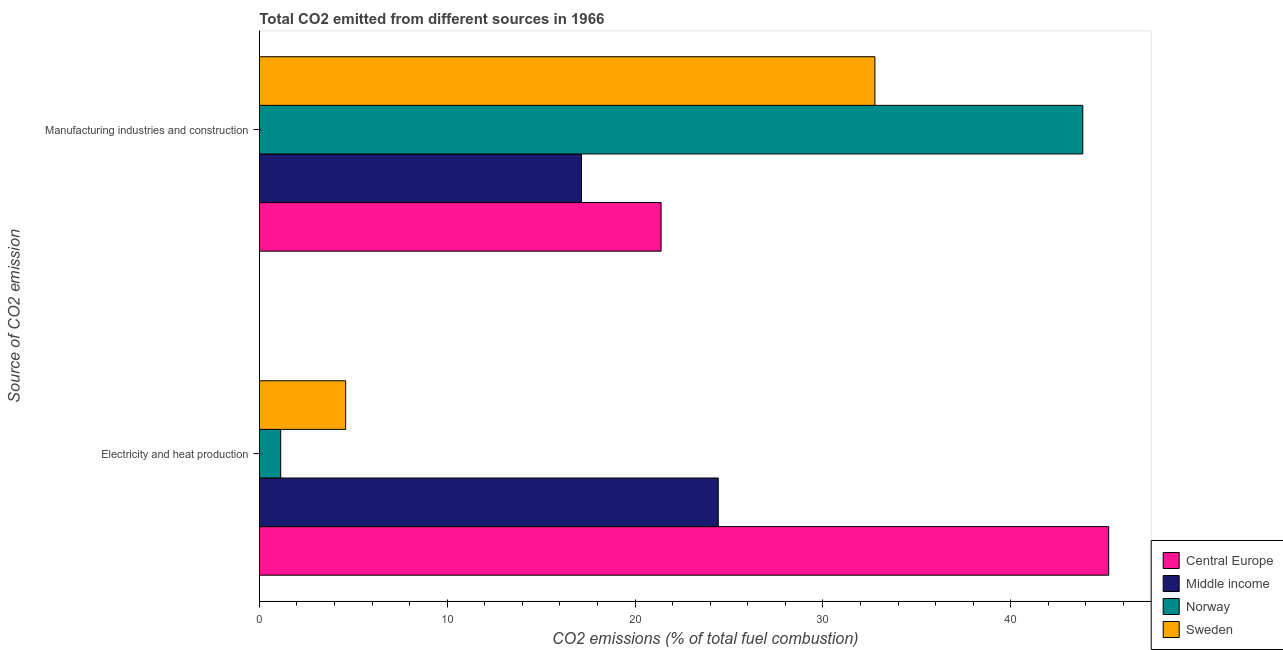How many groups of bars are there?
Your response must be concise. 2. Are the number of bars on each tick of the Y-axis equal?
Offer a terse response. Yes. How many bars are there on the 1st tick from the bottom?
Make the answer very short. 4. What is the label of the 1st group of bars from the top?
Give a very brief answer. Manufacturing industries and construction. What is the co2 emissions due to electricity and heat production in Sweden?
Offer a terse response. 4.6. Across all countries, what is the maximum co2 emissions due to manufacturing industries?
Ensure brevity in your answer.  43.83. Across all countries, what is the minimum co2 emissions due to electricity and heat production?
Provide a succinct answer. 1.14. In which country was the co2 emissions due to electricity and heat production minimum?
Your answer should be compact. Norway. What is the total co2 emissions due to manufacturing industries in the graph?
Keep it short and to the point. 115.13. What is the difference between the co2 emissions due to electricity and heat production in Central Europe and that in Norway?
Keep it short and to the point. 44.07. What is the difference between the co2 emissions due to manufacturing industries in Norway and the co2 emissions due to electricity and heat production in Central Europe?
Your response must be concise. -1.38. What is the average co2 emissions due to manufacturing industries per country?
Your answer should be compact. 28.78. What is the difference between the co2 emissions due to manufacturing industries and co2 emissions due to electricity and heat production in Middle income?
Ensure brevity in your answer.  -7.28. What is the ratio of the co2 emissions due to manufacturing industries in Sweden to that in Norway?
Provide a succinct answer. 0.75. What does the 2nd bar from the top in Manufacturing industries and construction represents?
Keep it short and to the point. Norway. What does the 1st bar from the bottom in Electricity and heat production represents?
Keep it short and to the point. Central Europe. Are all the bars in the graph horizontal?
Offer a very short reply. Yes. How many countries are there in the graph?
Offer a very short reply. 4. Does the graph contain any zero values?
Offer a very short reply. No. How are the legend labels stacked?
Make the answer very short. Vertical. What is the title of the graph?
Keep it short and to the point. Total CO2 emitted from different sources in 1966. Does "Congo (Republic)" appear as one of the legend labels in the graph?
Your answer should be very brief. No. What is the label or title of the X-axis?
Offer a very short reply. CO2 emissions (% of total fuel combustion). What is the label or title of the Y-axis?
Your response must be concise. Source of CO2 emission. What is the CO2 emissions (% of total fuel combustion) in Central Europe in Electricity and heat production?
Your answer should be very brief. 45.21. What is the CO2 emissions (% of total fuel combustion) in Middle income in Electricity and heat production?
Keep it short and to the point. 24.43. What is the CO2 emissions (% of total fuel combustion) of Norway in Electricity and heat production?
Keep it short and to the point. 1.14. What is the CO2 emissions (% of total fuel combustion) in Sweden in Electricity and heat production?
Make the answer very short. 4.6. What is the CO2 emissions (% of total fuel combustion) of Central Europe in Manufacturing industries and construction?
Make the answer very short. 21.39. What is the CO2 emissions (% of total fuel combustion) of Middle income in Manufacturing industries and construction?
Provide a short and direct response. 17.15. What is the CO2 emissions (% of total fuel combustion) of Norway in Manufacturing industries and construction?
Keep it short and to the point. 43.83. What is the CO2 emissions (% of total fuel combustion) in Sweden in Manufacturing industries and construction?
Provide a succinct answer. 32.77. Across all Source of CO2 emission, what is the maximum CO2 emissions (% of total fuel combustion) of Central Europe?
Provide a succinct answer. 45.21. Across all Source of CO2 emission, what is the maximum CO2 emissions (% of total fuel combustion) of Middle income?
Offer a terse response. 24.43. Across all Source of CO2 emission, what is the maximum CO2 emissions (% of total fuel combustion) of Norway?
Offer a terse response. 43.83. Across all Source of CO2 emission, what is the maximum CO2 emissions (% of total fuel combustion) in Sweden?
Provide a succinct answer. 32.77. Across all Source of CO2 emission, what is the minimum CO2 emissions (% of total fuel combustion) of Central Europe?
Provide a succinct answer. 21.39. Across all Source of CO2 emission, what is the minimum CO2 emissions (% of total fuel combustion) in Middle income?
Give a very brief answer. 17.15. Across all Source of CO2 emission, what is the minimum CO2 emissions (% of total fuel combustion) in Norway?
Provide a succinct answer. 1.14. Across all Source of CO2 emission, what is the minimum CO2 emissions (% of total fuel combustion) of Sweden?
Offer a terse response. 4.6. What is the total CO2 emissions (% of total fuel combustion) of Central Europe in the graph?
Keep it short and to the point. 66.6. What is the total CO2 emissions (% of total fuel combustion) of Middle income in the graph?
Keep it short and to the point. 41.57. What is the total CO2 emissions (% of total fuel combustion) in Norway in the graph?
Your answer should be compact. 44.97. What is the total CO2 emissions (% of total fuel combustion) of Sweden in the graph?
Offer a terse response. 37.36. What is the difference between the CO2 emissions (% of total fuel combustion) in Central Europe in Electricity and heat production and that in Manufacturing industries and construction?
Provide a succinct answer. 23.82. What is the difference between the CO2 emissions (% of total fuel combustion) of Middle income in Electricity and heat production and that in Manufacturing industries and construction?
Offer a very short reply. 7.28. What is the difference between the CO2 emissions (% of total fuel combustion) of Norway in Electricity and heat production and that in Manufacturing industries and construction?
Provide a succinct answer. -42.69. What is the difference between the CO2 emissions (% of total fuel combustion) in Sweden in Electricity and heat production and that in Manufacturing industries and construction?
Your answer should be very brief. -28.17. What is the difference between the CO2 emissions (% of total fuel combustion) in Central Europe in Electricity and heat production and the CO2 emissions (% of total fuel combustion) in Middle income in Manufacturing industries and construction?
Offer a terse response. 28.06. What is the difference between the CO2 emissions (% of total fuel combustion) of Central Europe in Electricity and heat production and the CO2 emissions (% of total fuel combustion) of Norway in Manufacturing industries and construction?
Make the answer very short. 1.38. What is the difference between the CO2 emissions (% of total fuel combustion) in Central Europe in Electricity and heat production and the CO2 emissions (% of total fuel combustion) in Sweden in Manufacturing industries and construction?
Offer a very short reply. 12.45. What is the difference between the CO2 emissions (% of total fuel combustion) in Middle income in Electricity and heat production and the CO2 emissions (% of total fuel combustion) in Norway in Manufacturing industries and construction?
Make the answer very short. -19.4. What is the difference between the CO2 emissions (% of total fuel combustion) of Middle income in Electricity and heat production and the CO2 emissions (% of total fuel combustion) of Sweden in Manufacturing industries and construction?
Keep it short and to the point. -8.34. What is the difference between the CO2 emissions (% of total fuel combustion) in Norway in Electricity and heat production and the CO2 emissions (% of total fuel combustion) in Sweden in Manufacturing industries and construction?
Keep it short and to the point. -31.63. What is the average CO2 emissions (% of total fuel combustion) of Central Europe per Source of CO2 emission?
Offer a terse response. 33.3. What is the average CO2 emissions (% of total fuel combustion) of Middle income per Source of CO2 emission?
Make the answer very short. 20.79. What is the average CO2 emissions (% of total fuel combustion) in Norway per Source of CO2 emission?
Your response must be concise. 22.48. What is the average CO2 emissions (% of total fuel combustion) in Sweden per Source of CO2 emission?
Keep it short and to the point. 18.68. What is the difference between the CO2 emissions (% of total fuel combustion) in Central Europe and CO2 emissions (% of total fuel combustion) in Middle income in Electricity and heat production?
Provide a short and direct response. 20.78. What is the difference between the CO2 emissions (% of total fuel combustion) in Central Europe and CO2 emissions (% of total fuel combustion) in Norway in Electricity and heat production?
Offer a terse response. 44.07. What is the difference between the CO2 emissions (% of total fuel combustion) in Central Europe and CO2 emissions (% of total fuel combustion) in Sweden in Electricity and heat production?
Provide a succinct answer. 40.61. What is the difference between the CO2 emissions (% of total fuel combustion) of Middle income and CO2 emissions (% of total fuel combustion) of Norway in Electricity and heat production?
Give a very brief answer. 23.29. What is the difference between the CO2 emissions (% of total fuel combustion) of Middle income and CO2 emissions (% of total fuel combustion) of Sweden in Electricity and heat production?
Ensure brevity in your answer.  19.83. What is the difference between the CO2 emissions (% of total fuel combustion) of Norway and CO2 emissions (% of total fuel combustion) of Sweden in Electricity and heat production?
Your response must be concise. -3.46. What is the difference between the CO2 emissions (% of total fuel combustion) of Central Europe and CO2 emissions (% of total fuel combustion) of Middle income in Manufacturing industries and construction?
Keep it short and to the point. 4.24. What is the difference between the CO2 emissions (% of total fuel combustion) of Central Europe and CO2 emissions (% of total fuel combustion) of Norway in Manufacturing industries and construction?
Offer a very short reply. -22.45. What is the difference between the CO2 emissions (% of total fuel combustion) of Central Europe and CO2 emissions (% of total fuel combustion) of Sweden in Manufacturing industries and construction?
Your answer should be very brief. -11.38. What is the difference between the CO2 emissions (% of total fuel combustion) in Middle income and CO2 emissions (% of total fuel combustion) in Norway in Manufacturing industries and construction?
Your answer should be very brief. -26.68. What is the difference between the CO2 emissions (% of total fuel combustion) in Middle income and CO2 emissions (% of total fuel combustion) in Sweden in Manufacturing industries and construction?
Give a very brief answer. -15.62. What is the difference between the CO2 emissions (% of total fuel combustion) in Norway and CO2 emissions (% of total fuel combustion) in Sweden in Manufacturing industries and construction?
Your answer should be compact. 11.07. What is the ratio of the CO2 emissions (% of total fuel combustion) of Central Europe in Electricity and heat production to that in Manufacturing industries and construction?
Ensure brevity in your answer.  2.11. What is the ratio of the CO2 emissions (% of total fuel combustion) in Middle income in Electricity and heat production to that in Manufacturing industries and construction?
Your response must be concise. 1.42. What is the ratio of the CO2 emissions (% of total fuel combustion) in Norway in Electricity and heat production to that in Manufacturing industries and construction?
Keep it short and to the point. 0.03. What is the ratio of the CO2 emissions (% of total fuel combustion) of Sweden in Electricity and heat production to that in Manufacturing industries and construction?
Offer a very short reply. 0.14. What is the difference between the highest and the second highest CO2 emissions (% of total fuel combustion) in Central Europe?
Your answer should be compact. 23.82. What is the difference between the highest and the second highest CO2 emissions (% of total fuel combustion) in Middle income?
Keep it short and to the point. 7.28. What is the difference between the highest and the second highest CO2 emissions (% of total fuel combustion) in Norway?
Offer a very short reply. 42.69. What is the difference between the highest and the second highest CO2 emissions (% of total fuel combustion) of Sweden?
Your response must be concise. 28.17. What is the difference between the highest and the lowest CO2 emissions (% of total fuel combustion) of Central Europe?
Make the answer very short. 23.82. What is the difference between the highest and the lowest CO2 emissions (% of total fuel combustion) of Middle income?
Your answer should be very brief. 7.28. What is the difference between the highest and the lowest CO2 emissions (% of total fuel combustion) of Norway?
Offer a terse response. 42.69. What is the difference between the highest and the lowest CO2 emissions (% of total fuel combustion) of Sweden?
Give a very brief answer. 28.17. 